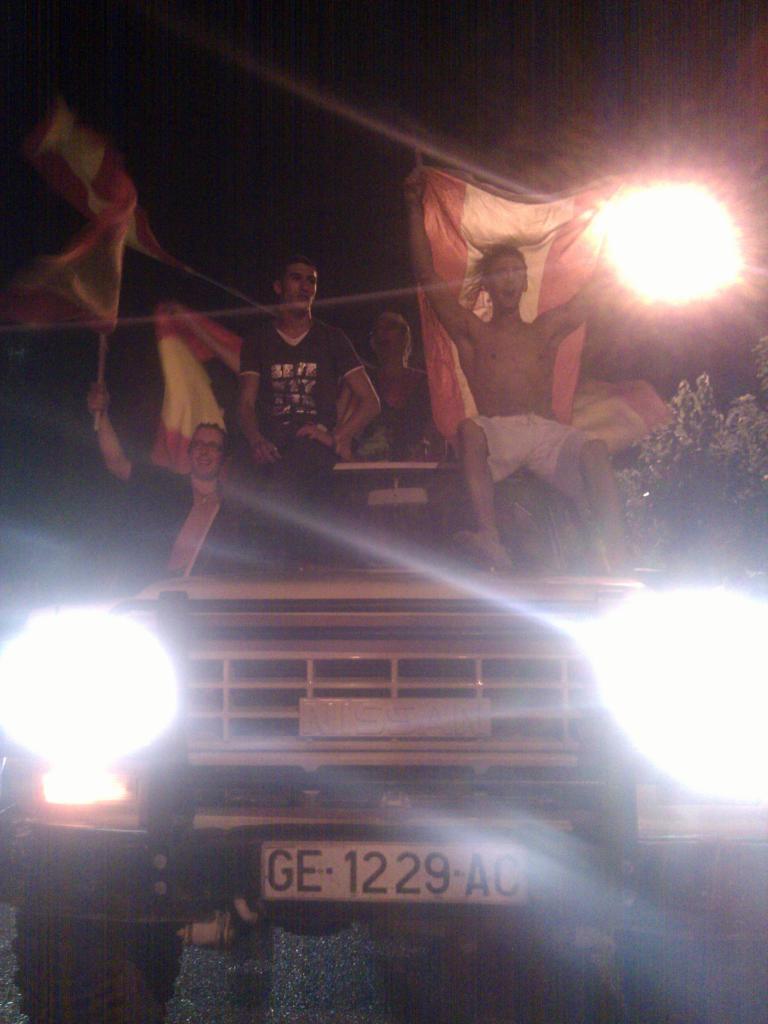How would you summarize this image in a sentence or two? There are three people who are sitting on a jeep. Three people are holding a flag in their hand. 